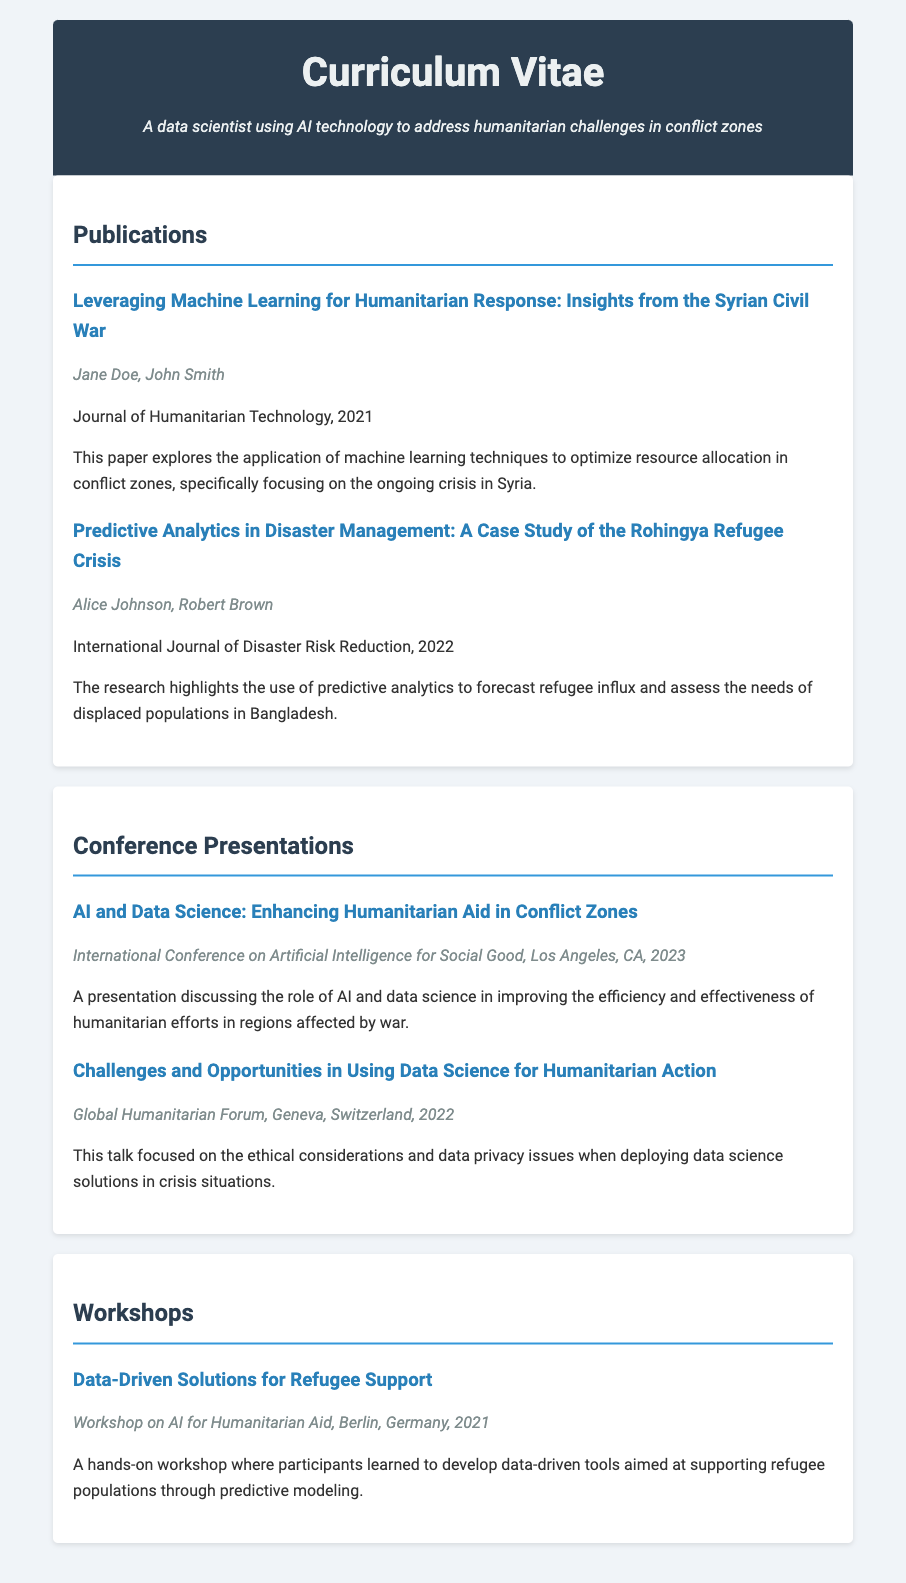what is the title of the first publication? The first publication title is mentioned in the document under the Publications section.
Answer: Leveraging Machine Learning for Humanitarian Response: Insights from the Syrian Civil War who is one of the authors of the second publication? The second publication lists the authors in its description.
Answer: Alice Johnson what year was the paper on predictive analytics published? The publication date is specified next to each publication title.
Answer: 2022 what was the focus of the presentation given at the International Conference on Artificial Intelligence for Social Good? The focus is summarized in the description provided under the presentation details.
Answer: Enhancing Humanitarian Aid in Conflict Zones which workshop took place in Berlin? The workshops are listed with specific titles and details about their locations.
Answer: Data-Driven Solutions for Refugee Support how many presentations are listed in total? The number of presentations can be determined by counting the listings under the Conference Presentations section.
Answer: 2 which journal published the first paper? The hosting journal for each publication is listed directly after the author names.
Answer: Journal of Humanitarian Technology what was discussed in the talk at the Global Humanitarian Forum? The specific topic is described in the summary of the presentation details.
Answer: Ethical considerations and data privacy issues what type of workshop was held in 2021? The nature of the workshop is indicated in the description under the Workshops section.
Answer: Hands-on workshop 